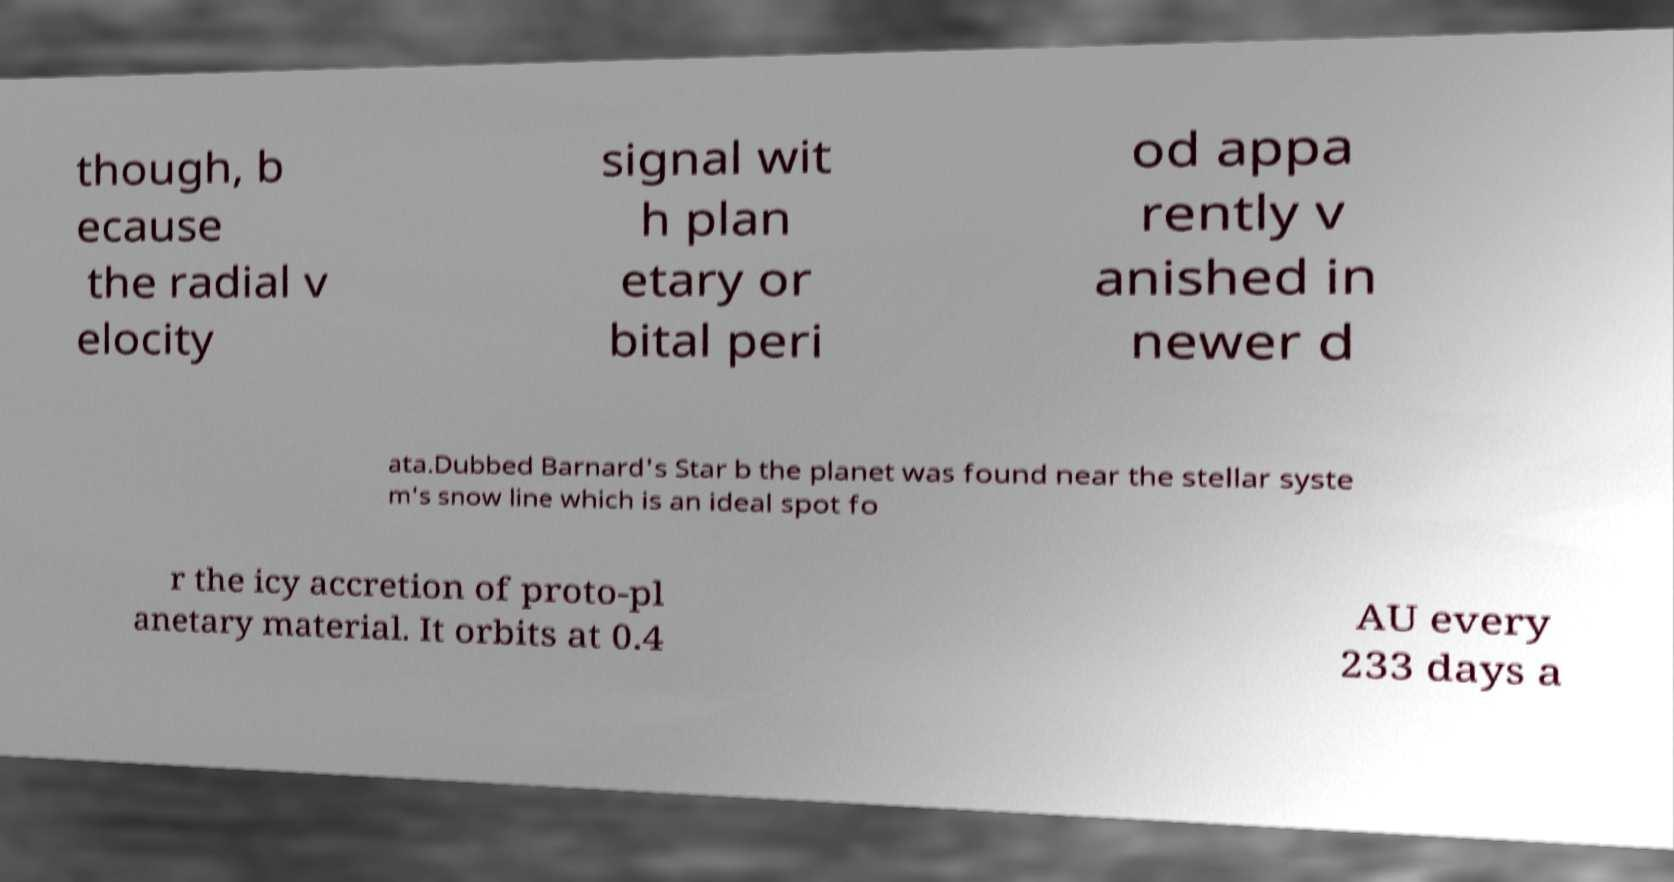There's text embedded in this image that I need extracted. Can you transcribe it verbatim? though, b ecause the radial v elocity signal wit h plan etary or bital peri od appa rently v anished in newer d ata.Dubbed Barnard's Star b the planet was found near the stellar syste m's snow line which is an ideal spot fo r the icy accretion of proto-pl anetary material. It orbits at 0.4 AU every 233 days a 